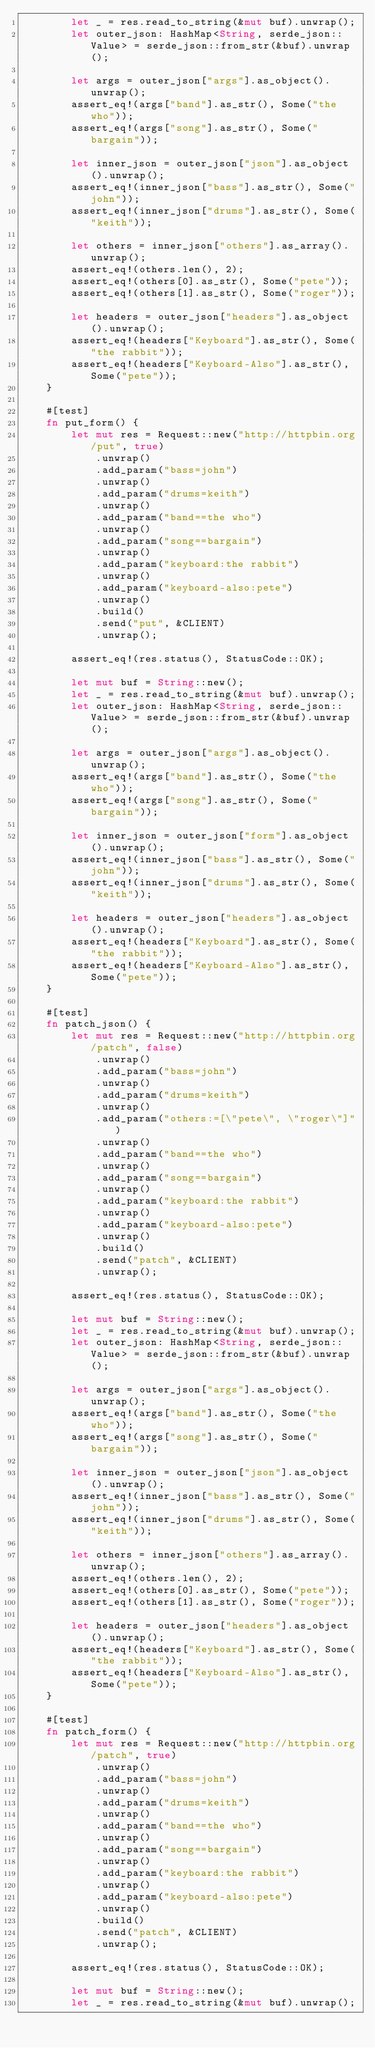Convert code to text. <code><loc_0><loc_0><loc_500><loc_500><_Rust_>        let _ = res.read_to_string(&mut buf).unwrap();
        let outer_json: HashMap<String, serde_json::Value> = serde_json::from_str(&buf).unwrap();

        let args = outer_json["args"].as_object().unwrap();
        assert_eq!(args["band"].as_str(), Some("the who"));
        assert_eq!(args["song"].as_str(), Some("bargain"));

        let inner_json = outer_json["json"].as_object().unwrap();
        assert_eq!(inner_json["bass"].as_str(), Some("john"));
        assert_eq!(inner_json["drums"].as_str(), Some("keith"));

        let others = inner_json["others"].as_array().unwrap();
        assert_eq!(others.len(), 2);
        assert_eq!(others[0].as_str(), Some("pete"));
        assert_eq!(others[1].as_str(), Some("roger"));

        let headers = outer_json["headers"].as_object().unwrap();
        assert_eq!(headers["Keyboard"].as_str(), Some("the rabbit"));
        assert_eq!(headers["Keyboard-Also"].as_str(), Some("pete"));
    }

    #[test]
    fn put_form() {
        let mut res = Request::new("http://httpbin.org/put", true)
            .unwrap()
            .add_param("bass=john")
            .unwrap()
            .add_param("drums=keith")
            .unwrap()
            .add_param("band==the who")
            .unwrap()
            .add_param("song==bargain")
            .unwrap()
            .add_param("keyboard:the rabbit")
            .unwrap()
            .add_param("keyboard-also:pete")
            .unwrap()
            .build()
            .send("put", &CLIENT)
            .unwrap();

        assert_eq!(res.status(), StatusCode::OK);

        let mut buf = String::new();
        let _ = res.read_to_string(&mut buf).unwrap();
        let outer_json: HashMap<String, serde_json::Value> = serde_json::from_str(&buf).unwrap();

        let args = outer_json["args"].as_object().unwrap();
        assert_eq!(args["band"].as_str(), Some("the who"));
        assert_eq!(args["song"].as_str(), Some("bargain"));

        let inner_json = outer_json["form"].as_object().unwrap();
        assert_eq!(inner_json["bass"].as_str(), Some("john"));
        assert_eq!(inner_json["drums"].as_str(), Some("keith"));

        let headers = outer_json["headers"].as_object().unwrap();
        assert_eq!(headers["Keyboard"].as_str(), Some("the rabbit"));
        assert_eq!(headers["Keyboard-Also"].as_str(), Some("pete"));
    }

    #[test]
    fn patch_json() {
        let mut res = Request::new("http://httpbin.org/patch", false)
            .unwrap()
            .add_param("bass=john")
            .unwrap()
            .add_param("drums=keith")
            .unwrap()
            .add_param("others:=[\"pete\", \"roger\"]")
            .unwrap()
            .add_param("band==the who")
            .unwrap()
            .add_param("song==bargain")
            .unwrap()
            .add_param("keyboard:the rabbit")
            .unwrap()
            .add_param("keyboard-also:pete")
            .unwrap()
            .build()
            .send("patch", &CLIENT)
            .unwrap();

        assert_eq!(res.status(), StatusCode::OK);

        let mut buf = String::new();
        let _ = res.read_to_string(&mut buf).unwrap();
        let outer_json: HashMap<String, serde_json::Value> = serde_json::from_str(&buf).unwrap();

        let args = outer_json["args"].as_object().unwrap();
        assert_eq!(args["band"].as_str(), Some("the who"));
        assert_eq!(args["song"].as_str(), Some("bargain"));

        let inner_json = outer_json["json"].as_object().unwrap();
        assert_eq!(inner_json["bass"].as_str(), Some("john"));
        assert_eq!(inner_json["drums"].as_str(), Some("keith"));

        let others = inner_json["others"].as_array().unwrap();
        assert_eq!(others.len(), 2);
        assert_eq!(others[0].as_str(), Some("pete"));
        assert_eq!(others[1].as_str(), Some("roger"));

        let headers = outer_json["headers"].as_object().unwrap();
        assert_eq!(headers["Keyboard"].as_str(), Some("the rabbit"));
        assert_eq!(headers["Keyboard-Also"].as_str(), Some("pete"));
    }

    #[test]
    fn patch_form() {
        let mut res = Request::new("http://httpbin.org/patch", true)
            .unwrap()
            .add_param("bass=john")
            .unwrap()
            .add_param("drums=keith")
            .unwrap()
            .add_param("band==the who")
            .unwrap()
            .add_param("song==bargain")
            .unwrap()
            .add_param("keyboard:the rabbit")
            .unwrap()
            .add_param("keyboard-also:pete")
            .unwrap()
            .build()
            .send("patch", &CLIENT)
            .unwrap();

        assert_eq!(res.status(), StatusCode::OK);

        let mut buf = String::new();
        let _ = res.read_to_string(&mut buf).unwrap();</code> 